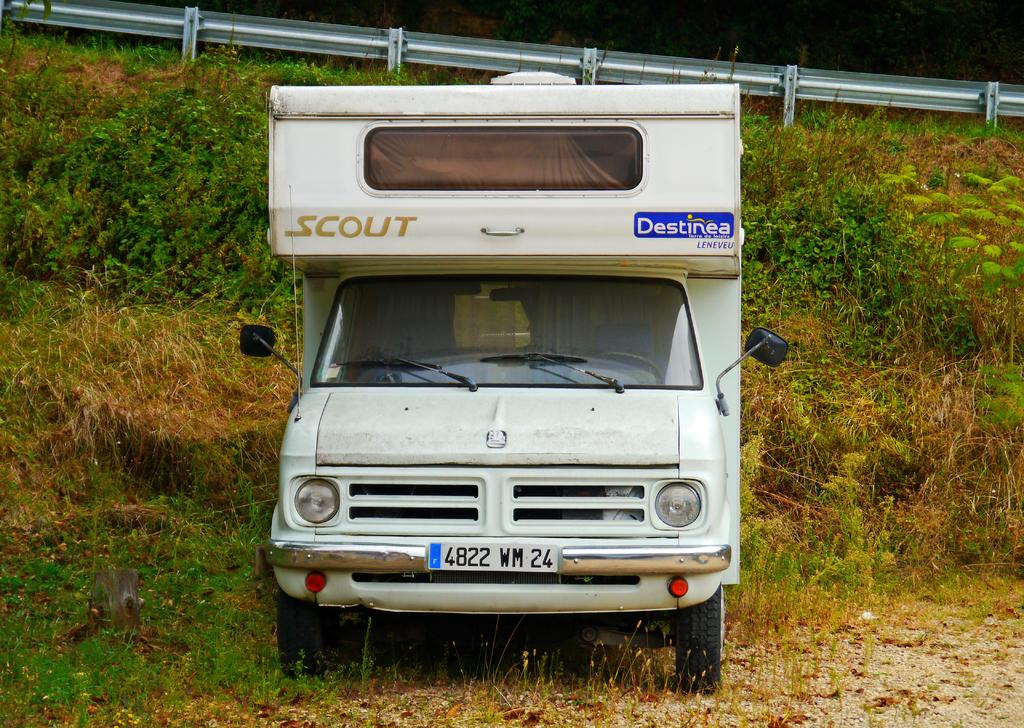What is the main subject of the image? There is a vehicle in the image. Can you describe the color of the vehicle? The vehicle is white in color. What can be seen in the background of the image? There are plants and fencing in the background of the image. What nation is the beggar from in the image? There is no beggar present in the image, so it is not possible to determine the nation they might be from. 